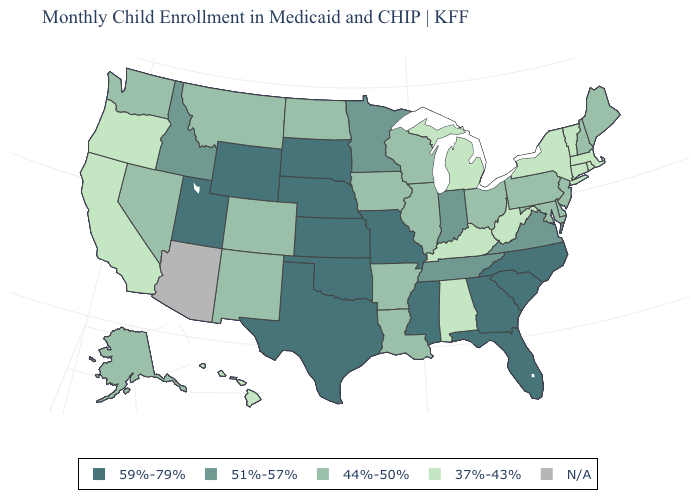What is the value of New Mexico?
Short answer required. 44%-50%. What is the value of Vermont?
Short answer required. 37%-43%. Does Texas have the highest value in the USA?
Short answer required. Yes. Name the states that have a value in the range 59%-79%?
Give a very brief answer. Florida, Georgia, Kansas, Mississippi, Missouri, Nebraska, North Carolina, Oklahoma, South Carolina, South Dakota, Texas, Utah, Wyoming. What is the value of New Hampshire?
Concise answer only. 44%-50%. What is the value of Ohio?
Keep it brief. 44%-50%. Among the states that border Iowa , which have the highest value?
Concise answer only. Missouri, Nebraska, South Dakota. What is the value of Wyoming?
Quick response, please. 59%-79%. Name the states that have a value in the range N/A?
Write a very short answer. Arizona. What is the value of North Dakota?
Quick response, please. 44%-50%. Name the states that have a value in the range 44%-50%?
Keep it brief. Alaska, Arkansas, Colorado, Delaware, Illinois, Iowa, Louisiana, Maine, Maryland, Montana, Nevada, New Hampshire, New Jersey, New Mexico, North Dakota, Ohio, Pennsylvania, Washington, Wisconsin. Name the states that have a value in the range 44%-50%?
Concise answer only. Alaska, Arkansas, Colorado, Delaware, Illinois, Iowa, Louisiana, Maine, Maryland, Montana, Nevada, New Hampshire, New Jersey, New Mexico, North Dakota, Ohio, Pennsylvania, Washington, Wisconsin. What is the highest value in states that border Rhode Island?
Concise answer only. 37%-43%. What is the value of Colorado?
Quick response, please. 44%-50%. Name the states that have a value in the range 37%-43%?
Write a very short answer. Alabama, California, Connecticut, Hawaii, Kentucky, Massachusetts, Michigan, New York, Oregon, Rhode Island, Vermont, West Virginia. 